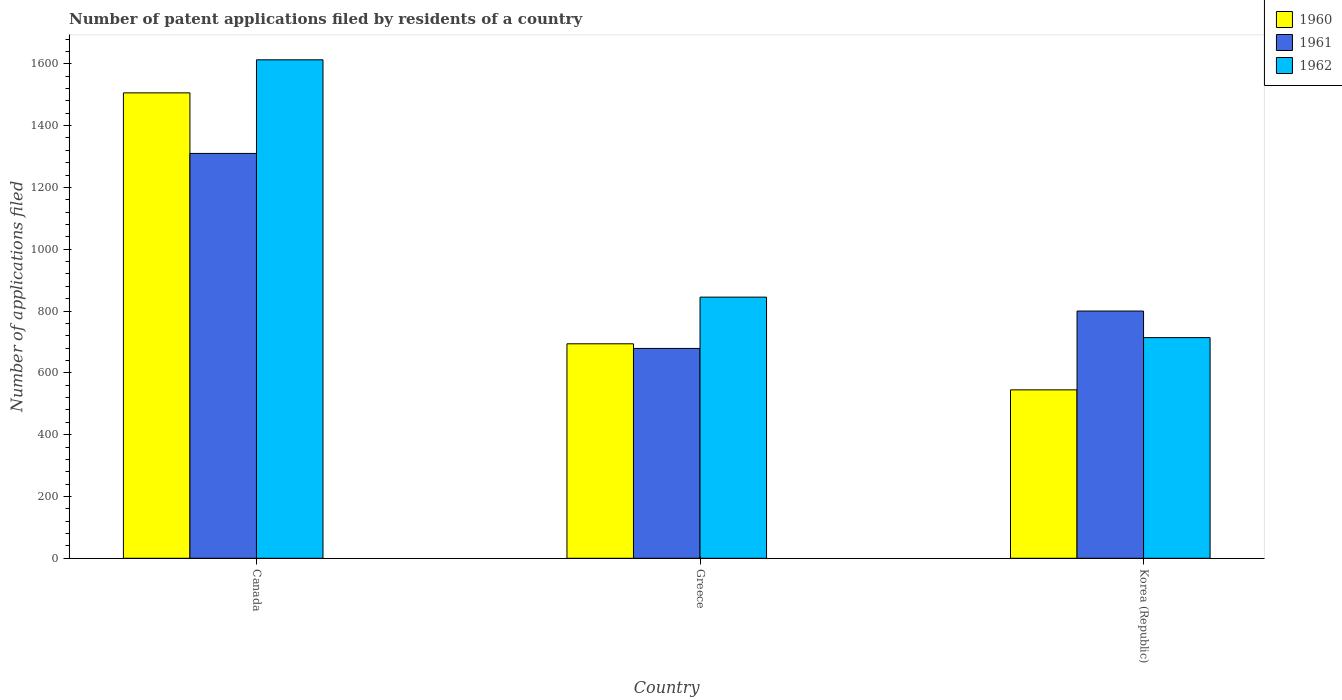How many groups of bars are there?
Give a very brief answer. 3. How many bars are there on the 2nd tick from the left?
Give a very brief answer. 3. What is the label of the 2nd group of bars from the left?
Your response must be concise. Greece. In how many cases, is the number of bars for a given country not equal to the number of legend labels?
Your response must be concise. 0. What is the number of applications filed in 1962 in Canada?
Offer a very short reply. 1613. Across all countries, what is the maximum number of applications filed in 1962?
Your response must be concise. 1613. Across all countries, what is the minimum number of applications filed in 1962?
Give a very brief answer. 714. In which country was the number of applications filed in 1962 minimum?
Offer a terse response. Korea (Republic). What is the total number of applications filed in 1961 in the graph?
Your response must be concise. 2789. What is the difference between the number of applications filed in 1961 in Canada and that in Korea (Republic)?
Your response must be concise. 510. What is the difference between the number of applications filed in 1961 in Canada and the number of applications filed in 1960 in Greece?
Your response must be concise. 616. What is the average number of applications filed in 1961 per country?
Your response must be concise. 929.67. What is the difference between the number of applications filed of/in 1961 and number of applications filed of/in 1962 in Canada?
Make the answer very short. -303. In how many countries, is the number of applications filed in 1961 greater than 1200?
Provide a short and direct response. 1. What is the ratio of the number of applications filed in 1962 in Canada to that in Greece?
Your answer should be compact. 1.91. Is the number of applications filed in 1961 in Canada less than that in Korea (Republic)?
Your response must be concise. No. Is the difference between the number of applications filed in 1961 in Greece and Korea (Republic) greater than the difference between the number of applications filed in 1962 in Greece and Korea (Republic)?
Your answer should be compact. No. What is the difference between the highest and the second highest number of applications filed in 1960?
Your response must be concise. -961. What is the difference between the highest and the lowest number of applications filed in 1961?
Offer a terse response. 631. In how many countries, is the number of applications filed in 1961 greater than the average number of applications filed in 1961 taken over all countries?
Offer a very short reply. 1. Is the sum of the number of applications filed in 1962 in Canada and Greece greater than the maximum number of applications filed in 1960 across all countries?
Keep it short and to the point. Yes. What does the 2nd bar from the right in Greece represents?
Your answer should be compact. 1961. Is it the case that in every country, the sum of the number of applications filed in 1962 and number of applications filed in 1961 is greater than the number of applications filed in 1960?
Make the answer very short. Yes. What is the difference between two consecutive major ticks on the Y-axis?
Provide a short and direct response. 200. Are the values on the major ticks of Y-axis written in scientific E-notation?
Provide a short and direct response. No. Does the graph contain grids?
Offer a very short reply. No. How many legend labels are there?
Provide a short and direct response. 3. What is the title of the graph?
Your answer should be very brief. Number of patent applications filed by residents of a country. Does "1977" appear as one of the legend labels in the graph?
Provide a short and direct response. No. What is the label or title of the Y-axis?
Your answer should be very brief. Number of applications filed. What is the Number of applications filed of 1960 in Canada?
Make the answer very short. 1506. What is the Number of applications filed in 1961 in Canada?
Make the answer very short. 1310. What is the Number of applications filed in 1962 in Canada?
Keep it short and to the point. 1613. What is the Number of applications filed of 1960 in Greece?
Offer a terse response. 694. What is the Number of applications filed of 1961 in Greece?
Keep it short and to the point. 679. What is the Number of applications filed in 1962 in Greece?
Provide a short and direct response. 845. What is the Number of applications filed of 1960 in Korea (Republic)?
Give a very brief answer. 545. What is the Number of applications filed of 1961 in Korea (Republic)?
Ensure brevity in your answer.  800. What is the Number of applications filed in 1962 in Korea (Republic)?
Ensure brevity in your answer.  714. Across all countries, what is the maximum Number of applications filed of 1960?
Give a very brief answer. 1506. Across all countries, what is the maximum Number of applications filed of 1961?
Keep it short and to the point. 1310. Across all countries, what is the maximum Number of applications filed of 1962?
Make the answer very short. 1613. Across all countries, what is the minimum Number of applications filed of 1960?
Make the answer very short. 545. Across all countries, what is the minimum Number of applications filed of 1961?
Offer a very short reply. 679. Across all countries, what is the minimum Number of applications filed of 1962?
Offer a very short reply. 714. What is the total Number of applications filed of 1960 in the graph?
Your answer should be very brief. 2745. What is the total Number of applications filed of 1961 in the graph?
Offer a very short reply. 2789. What is the total Number of applications filed of 1962 in the graph?
Provide a short and direct response. 3172. What is the difference between the Number of applications filed of 1960 in Canada and that in Greece?
Your answer should be very brief. 812. What is the difference between the Number of applications filed in 1961 in Canada and that in Greece?
Provide a short and direct response. 631. What is the difference between the Number of applications filed in 1962 in Canada and that in Greece?
Give a very brief answer. 768. What is the difference between the Number of applications filed of 1960 in Canada and that in Korea (Republic)?
Your answer should be compact. 961. What is the difference between the Number of applications filed of 1961 in Canada and that in Korea (Republic)?
Give a very brief answer. 510. What is the difference between the Number of applications filed in 1962 in Canada and that in Korea (Republic)?
Your answer should be compact. 899. What is the difference between the Number of applications filed of 1960 in Greece and that in Korea (Republic)?
Your answer should be very brief. 149. What is the difference between the Number of applications filed of 1961 in Greece and that in Korea (Republic)?
Ensure brevity in your answer.  -121. What is the difference between the Number of applications filed of 1962 in Greece and that in Korea (Republic)?
Keep it short and to the point. 131. What is the difference between the Number of applications filed of 1960 in Canada and the Number of applications filed of 1961 in Greece?
Make the answer very short. 827. What is the difference between the Number of applications filed in 1960 in Canada and the Number of applications filed in 1962 in Greece?
Offer a terse response. 661. What is the difference between the Number of applications filed of 1961 in Canada and the Number of applications filed of 1962 in Greece?
Your answer should be very brief. 465. What is the difference between the Number of applications filed of 1960 in Canada and the Number of applications filed of 1961 in Korea (Republic)?
Ensure brevity in your answer.  706. What is the difference between the Number of applications filed of 1960 in Canada and the Number of applications filed of 1962 in Korea (Republic)?
Ensure brevity in your answer.  792. What is the difference between the Number of applications filed in 1961 in Canada and the Number of applications filed in 1962 in Korea (Republic)?
Keep it short and to the point. 596. What is the difference between the Number of applications filed in 1960 in Greece and the Number of applications filed in 1961 in Korea (Republic)?
Your response must be concise. -106. What is the difference between the Number of applications filed of 1960 in Greece and the Number of applications filed of 1962 in Korea (Republic)?
Offer a very short reply. -20. What is the difference between the Number of applications filed of 1961 in Greece and the Number of applications filed of 1962 in Korea (Republic)?
Ensure brevity in your answer.  -35. What is the average Number of applications filed of 1960 per country?
Give a very brief answer. 915. What is the average Number of applications filed of 1961 per country?
Your answer should be compact. 929.67. What is the average Number of applications filed of 1962 per country?
Your answer should be very brief. 1057.33. What is the difference between the Number of applications filed of 1960 and Number of applications filed of 1961 in Canada?
Provide a succinct answer. 196. What is the difference between the Number of applications filed of 1960 and Number of applications filed of 1962 in Canada?
Offer a very short reply. -107. What is the difference between the Number of applications filed of 1961 and Number of applications filed of 1962 in Canada?
Offer a very short reply. -303. What is the difference between the Number of applications filed in 1960 and Number of applications filed in 1961 in Greece?
Offer a terse response. 15. What is the difference between the Number of applications filed in 1960 and Number of applications filed in 1962 in Greece?
Offer a very short reply. -151. What is the difference between the Number of applications filed in 1961 and Number of applications filed in 1962 in Greece?
Your response must be concise. -166. What is the difference between the Number of applications filed in 1960 and Number of applications filed in 1961 in Korea (Republic)?
Offer a terse response. -255. What is the difference between the Number of applications filed in 1960 and Number of applications filed in 1962 in Korea (Republic)?
Offer a terse response. -169. What is the difference between the Number of applications filed in 1961 and Number of applications filed in 1962 in Korea (Republic)?
Ensure brevity in your answer.  86. What is the ratio of the Number of applications filed of 1960 in Canada to that in Greece?
Provide a succinct answer. 2.17. What is the ratio of the Number of applications filed of 1961 in Canada to that in Greece?
Give a very brief answer. 1.93. What is the ratio of the Number of applications filed in 1962 in Canada to that in Greece?
Provide a succinct answer. 1.91. What is the ratio of the Number of applications filed in 1960 in Canada to that in Korea (Republic)?
Provide a succinct answer. 2.76. What is the ratio of the Number of applications filed in 1961 in Canada to that in Korea (Republic)?
Provide a succinct answer. 1.64. What is the ratio of the Number of applications filed in 1962 in Canada to that in Korea (Republic)?
Provide a succinct answer. 2.26. What is the ratio of the Number of applications filed of 1960 in Greece to that in Korea (Republic)?
Ensure brevity in your answer.  1.27. What is the ratio of the Number of applications filed of 1961 in Greece to that in Korea (Republic)?
Offer a very short reply. 0.85. What is the ratio of the Number of applications filed of 1962 in Greece to that in Korea (Republic)?
Your response must be concise. 1.18. What is the difference between the highest and the second highest Number of applications filed of 1960?
Offer a very short reply. 812. What is the difference between the highest and the second highest Number of applications filed in 1961?
Your answer should be compact. 510. What is the difference between the highest and the second highest Number of applications filed in 1962?
Give a very brief answer. 768. What is the difference between the highest and the lowest Number of applications filed of 1960?
Your answer should be very brief. 961. What is the difference between the highest and the lowest Number of applications filed in 1961?
Offer a terse response. 631. What is the difference between the highest and the lowest Number of applications filed of 1962?
Your response must be concise. 899. 